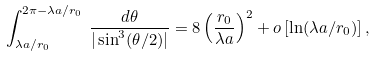Convert formula to latex. <formula><loc_0><loc_0><loc_500><loc_500>\int _ { \lambda a / r _ { 0 } } ^ { 2 \pi - \lambda a / r _ { 0 } } \, \frac { d \theta } { | \sin ^ { 3 } ( \theta / 2 ) | } = 8 \left ( \frac { r _ { 0 } } { \lambda a } \right ) ^ { 2 } + o \left [ \ln ( \lambda a / r _ { 0 } ) \right ] ,</formula> 